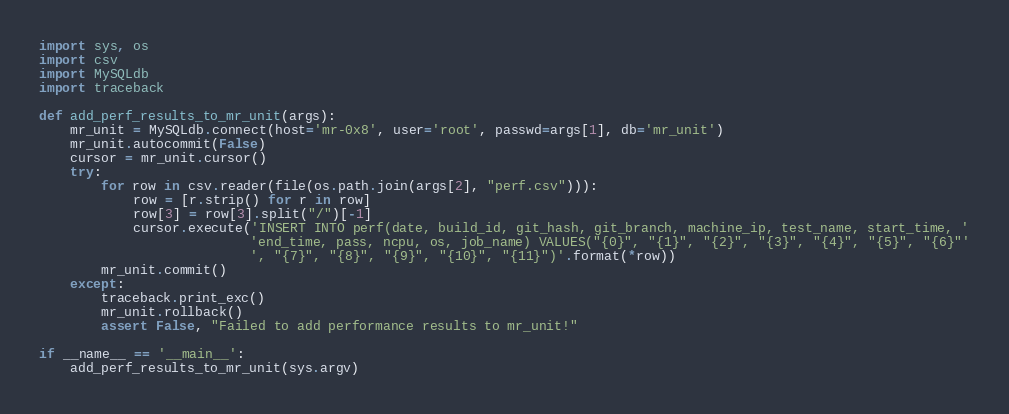<code> <loc_0><loc_0><loc_500><loc_500><_Python_>import sys, os
import csv
import MySQLdb
import traceback

def add_perf_results_to_mr_unit(args):
    mr_unit = MySQLdb.connect(host='mr-0x8', user='root', passwd=args[1], db='mr_unit')
    mr_unit.autocommit(False)
    cursor = mr_unit.cursor()
    try:
        for row in csv.reader(file(os.path.join(args[2], "perf.csv"))):
            row = [r.strip() for r in row]
            row[3] = row[3].split("/")[-1]
            cursor.execute('INSERT INTO perf(date, build_id, git_hash, git_branch, machine_ip, test_name, start_time, '
                           'end_time, pass, ncpu, os, job_name) VALUES("{0}", "{1}", "{2}", "{3}", "{4}", "{5}", "{6}"'
                           ', "{7}", "{8}", "{9}", "{10}", "{11}")'.format(*row))
        mr_unit.commit()
    except:
        traceback.print_exc()
        mr_unit.rollback()
        assert False, "Failed to add performance results to mr_unit!"

if __name__ == '__main__':
    add_perf_results_to_mr_unit(sys.argv)</code> 